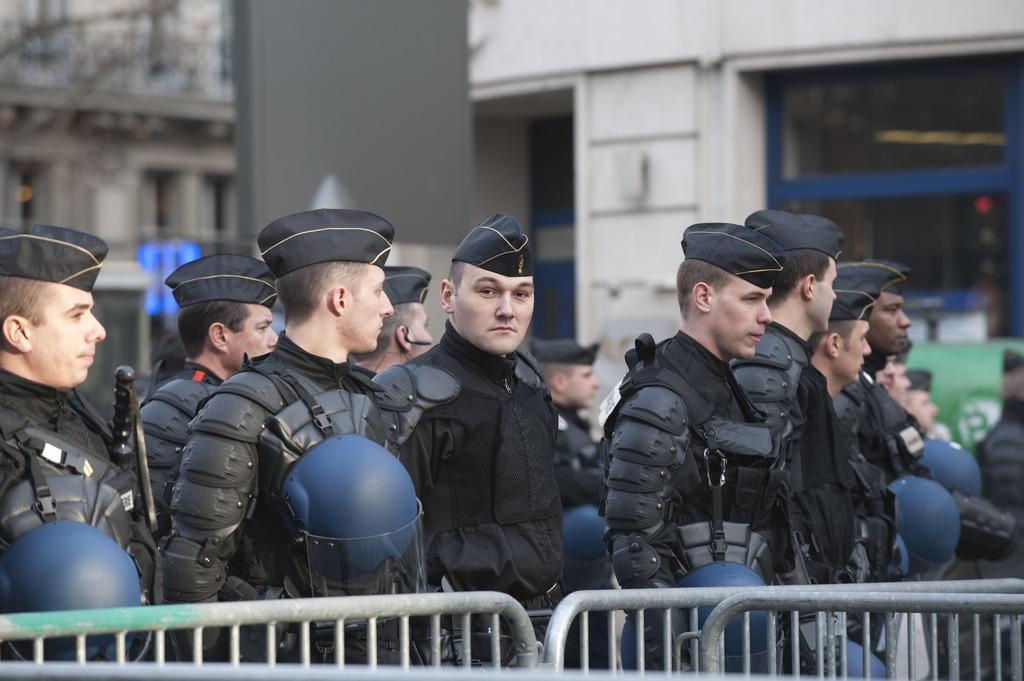Can you describe this image briefly? In the picture there are railings in the foreground, behind the railings there are a group of people with similar costumes, the background of the people is blur. 